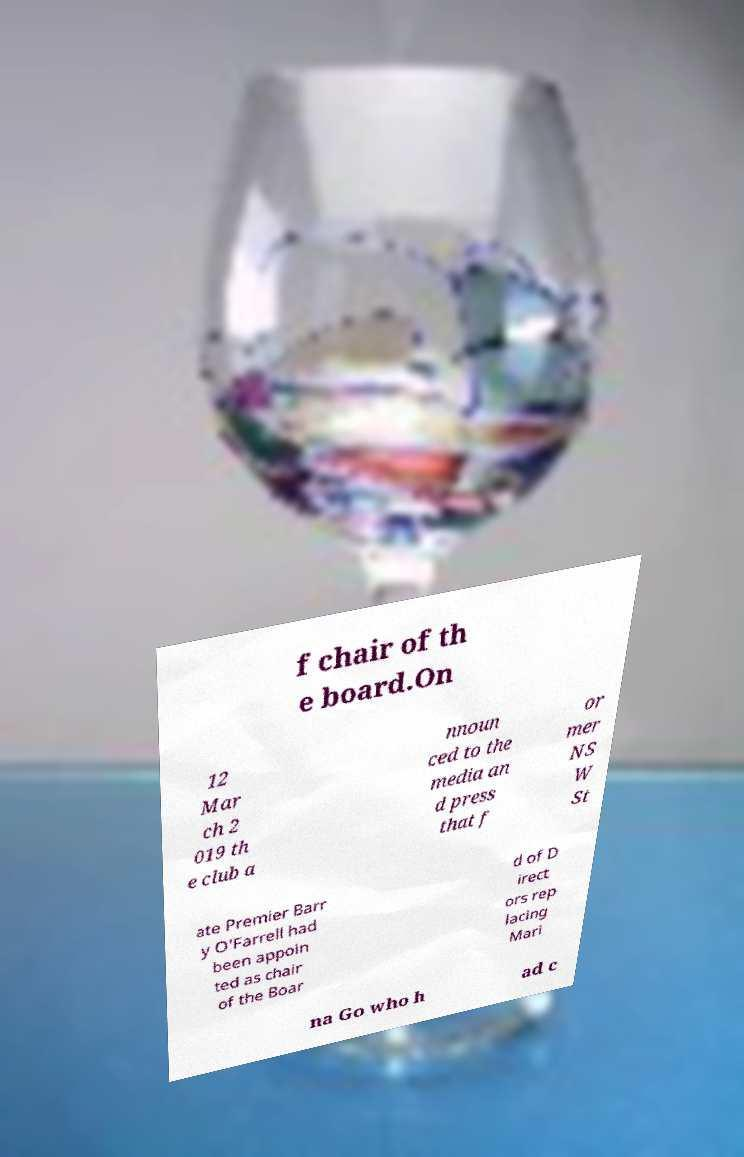Please identify and transcribe the text found in this image. f chair of th e board.On 12 Mar ch 2 019 th e club a nnoun ced to the media an d press that f or mer NS W St ate Premier Barr y O'Farrell had been appoin ted as chair of the Boar d of D irect ors rep lacing Mari na Go who h ad c 